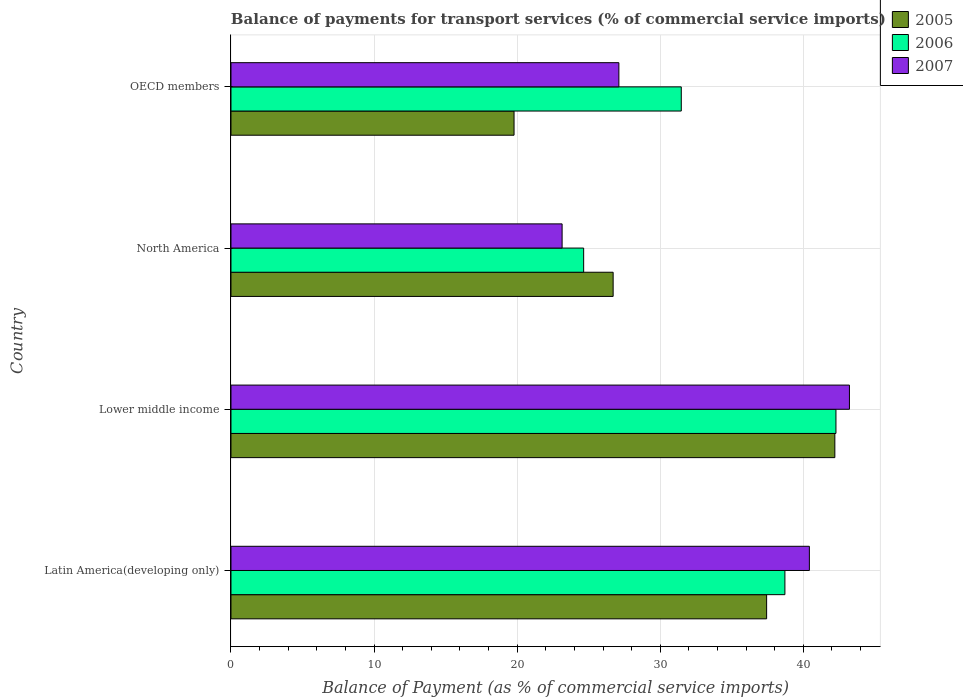How many bars are there on the 2nd tick from the bottom?
Offer a very short reply. 3. What is the label of the 2nd group of bars from the top?
Your answer should be compact. North America. What is the balance of payments for transport services in 2005 in Latin America(developing only)?
Keep it short and to the point. 37.43. Across all countries, what is the maximum balance of payments for transport services in 2007?
Provide a succinct answer. 43.22. Across all countries, what is the minimum balance of payments for transport services in 2005?
Provide a succinct answer. 19.78. In which country was the balance of payments for transport services in 2007 maximum?
Ensure brevity in your answer.  Lower middle income. In which country was the balance of payments for transport services in 2005 minimum?
Ensure brevity in your answer.  OECD members. What is the total balance of payments for transport services in 2006 in the graph?
Offer a terse response. 137.1. What is the difference between the balance of payments for transport services in 2006 in Lower middle income and that in North America?
Your response must be concise. 17.63. What is the difference between the balance of payments for transport services in 2006 in Lower middle income and the balance of payments for transport services in 2007 in Latin America(developing only)?
Ensure brevity in your answer.  1.86. What is the average balance of payments for transport services in 2006 per country?
Your answer should be very brief. 34.28. What is the difference between the balance of payments for transport services in 2006 and balance of payments for transport services in 2007 in Lower middle income?
Keep it short and to the point. -0.94. What is the ratio of the balance of payments for transport services in 2005 in Latin America(developing only) to that in OECD members?
Give a very brief answer. 1.89. What is the difference between the highest and the second highest balance of payments for transport services in 2007?
Offer a very short reply. 2.8. What is the difference between the highest and the lowest balance of payments for transport services in 2007?
Offer a terse response. 20.08. In how many countries, is the balance of payments for transport services in 2007 greater than the average balance of payments for transport services in 2007 taken over all countries?
Your answer should be very brief. 2. Is it the case that in every country, the sum of the balance of payments for transport services in 2006 and balance of payments for transport services in 2005 is greater than the balance of payments for transport services in 2007?
Offer a terse response. Yes. How many countries are there in the graph?
Your answer should be compact. 4. Does the graph contain any zero values?
Offer a very short reply. No. Where does the legend appear in the graph?
Your response must be concise. Top right. How many legend labels are there?
Your response must be concise. 3. What is the title of the graph?
Your answer should be compact. Balance of payments for transport services (% of commercial service imports). Does "2007" appear as one of the legend labels in the graph?
Your answer should be compact. Yes. What is the label or title of the X-axis?
Your response must be concise. Balance of Payment (as % of commercial service imports). What is the Balance of Payment (as % of commercial service imports) in 2005 in Latin America(developing only)?
Make the answer very short. 37.43. What is the Balance of Payment (as % of commercial service imports) of 2006 in Latin America(developing only)?
Your answer should be compact. 38.71. What is the Balance of Payment (as % of commercial service imports) of 2007 in Latin America(developing only)?
Offer a very short reply. 40.42. What is the Balance of Payment (as % of commercial service imports) in 2005 in Lower middle income?
Your answer should be compact. 42.2. What is the Balance of Payment (as % of commercial service imports) in 2006 in Lower middle income?
Ensure brevity in your answer.  42.28. What is the Balance of Payment (as % of commercial service imports) in 2007 in Lower middle income?
Your answer should be compact. 43.22. What is the Balance of Payment (as % of commercial service imports) of 2005 in North America?
Your answer should be compact. 26.71. What is the Balance of Payment (as % of commercial service imports) in 2006 in North America?
Offer a terse response. 24.65. What is the Balance of Payment (as % of commercial service imports) in 2007 in North America?
Provide a short and direct response. 23.14. What is the Balance of Payment (as % of commercial service imports) of 2005 in OECD members?
Provide a short and direct response. 19.78. What is the Balance of Payment (as % of commercial service imports) in 2006 in OECD members?
Give a very brief answer. 31.47. What is the Balance of Payment (as % of commercial service imports) in 2007 in OECD members?
Keep it short and to the point. 27.11. Across all countries, what is the maximum Balance of Payment (as % of commercial service imports) in 2005?
Provide a succinct answer. 42.2. Across all countries, what is the maximum Balance of Payment (as % of commercial service imports) in 2006?
Make the answer very short. 42.28. Across all countries, what is the maximum Balance of Payment (as % of commercial service imports) of 2007?
Offer a very short reply. 43.22. Across all countries, what is the minimum Balance of Payment (as % of commercial service imports) in 2005?
Offer a terse response. 19.78. Across all countries, what is the minimum Balance of Payment (as % of commercial service imports) in 2006?
Make the answer very short. 24.65. Across all countries, what is the minimum Balance of Payment (as % of commercial service imports) in 2007?
Provide a succinct answer. 23.14. What is the total Balance of Payment (as % of commercial service imports) in 2005 in the graph?
Your answer should be compact. 126.12. What is the total Balance of Payment (as % of commercial service imports) in 2006 in the graph?
Ensure brevity in your answer.  137.1. What is the total Balance of Payment (as % of commercial service imports) of 2007 in the graph?
Make the answer very short. 133.89. What is the difference between the Balance of Payment (as % of commercial service imports) of 2005 in Latin America(developing only) and that in Lower middle income?
Offer a terse response. -4.77. What is the difference between the Balance of Payment (as % of commercial service imports) in 2006 in Latin America(developing only) and that in Lower middle income?
Provide a short and direct response. -3.57. What is the difference between the Balance of Payment (as % of commercial service imports) in 2007 in Latin America(developing only) and that in Lower middle income?
Keep it short and to the point. -2.8. What is the difference between the Balance of Payment (as % of commercial service imports) of 2005 in Latin America(developing only) and that in North America?
Offer a terse response. 10.73. What is the difference between the Balance of Payment (as % of commercial service imports) in 2006 in Latin America(developing only) and that in North America?
Your response must be concise. 14.06. What is the difference between the Balance of Payment (as % of commercial service imports) of 2007 in Latin America(developing only) and that in North America?
Give a very brief answer. 17.28. What is the difference between the Balance of Payment (as % of commercial service imports) in 2005 in Latin America(developing only) and that in OECD members?
Make the answer very short. 17.65. What is the difference between the Balance of Payment (as % of commercial service imports) in 2006 in Latin America(developing only) and that in OECD members?
Ensure brevity in your answer.  7.24. What is the difference between the Balance of Payment (as % of commercial service imports) in 2007 in Latin America(developing only) and that in OECD members?
Make the answer very short. 13.31. What is the difference between the Balance of Payment (as % of commercial service imports) of 2005 in Lower middle income and that in North America?
Ensure brevity in your answer.  15.49. What is the difference between the Balance of Payment (as % of commercial service imports) of 2006 in Lower middle income and that in North America?
Offer a very short reply. 17.63. What is the difference between the Balance of Payment (as % of commercial service imports) of 2007 in Lower middle income and that in North America?
Your response must be concise. 20.08. What is the difference between the Balance of Payment (as % of commercial service imports) in 2005 in Lower middle income and that in OECD members?
Give a very brief answer. 22.42. What is the difference between the Balance of Payment (as % of commercial service imports) in 2006 in Lower middle income and that in OECD members?
Keep it short and to the point. 10.81. What is the difference between the Balance of Payment (as % of commercial service imports) of 2007 in Lower middle income and that in OECD members?
Your answer should be compact. 16.11. What is the difference between the Balance of Payment (as % of commercial service imports) of 2005 in North America and that in OECD members?
Make the answer very short. 6.93. What is the difference between the Balance of Payment (as % of commercial service imports) of 2006 in North America and that in OECD members?
Your answer should be very brief. -6.82. What is the difference between the Balance of Payment (as % of commercial service imports) in 2007 in North America and that in OECD members?
Your response must be concise. -3.97. What is the difference between the Balance of Payment (as % of commercial service imports) of 2005 in Latin America(developing only) and the Balance of Payment (as % of commercial service imports) of 2006 in Lower middle income?
Your answer should be very brief. -4.84. What is the difference between the Balance of Payment (as % of commercial service imports) in 2005 in Latin America(developing only) and the Balance of Payment (as % of commercial service imports) in 2007 in Lower middle income?
Make the answer very short. -5.79. What is the difference between the Balance of Payment (as % of commercial service imports) of 2006 in Latin America(developing only) and the Balance of Payment (as % of commercial service imports) of 2007 in Lower middle income?
Offer a terse response. -4.51. What is the difference between the Balance of Payment (as % of commercial service imports) of 2005 in Latin America(developing only) and the Balance of Payment (as % of commercial service imports) of 2006 in North America?
Your response must be concise. 12.79. What is the difference between the Balance of Payment (as % of commercial service imports) of 2005 in Latin America(developing only) and the Balance of Payment (as % of commercial service imports) of 2007 in North America?
Your answer should be very brief. 14.29. What is the difference between the Balance of Payment (as % of commercial service imports) of 2006 in Latin America(developing only) and the Balance of Payment (as % of commercial service imports) of 2007 in North America?
Provide a short and direct response. 15.57. What is the difference between the Balance of Payment (as % of commercial service imports) of 2005 in Latin America(developing only) and the Balance of Payment (as % of commercial service imports) of 2006 in OECD members?
Your response must be concise. 5.96. What is the difference between the Balance of Payment (as % of commercial service imports) in 2005 in Latin America(developing only) and the Balance of Payment (as % of commercial service imports) in 2007 in OECD members?
Your response must be concise. 10.33. What is the difference between the Balance of Payment (as % of commercial service imports) of 2006 in Latin America(developing only) and the Balance of Payment (as % of commercial service imports) of 2007 in OECD members?
Offer a terse response. 11.6. What is the difference between the Balance of Payment (as % of commercial service imports) in 2005 in Lower middle income and the Balance of Payment (as % of commercial service imports) in 2006 in North America?
Your response must be concise. 17.55. What is the difference between the Balance of Payment (as % of commercial service imports) in 2005 in Lower middle income and the Balance of Payment (as % of commercial service imports) in 2007 in North America?
Make the answer very short. 19.06. What is the difference between the Balance of Payment (as % of commercial service imports) of 2006 in Lower middle income and the Balance of Payment (as % of commercial service imports) of 2007 in North America?
Provide a succinct answer. 19.14. What is the difference between the Balance of Payment (as % of commercial service imports) of 2005 in Lower middle income and the Balance of Payment (as % of commercial service imports) of 2006 in OECD members?
Keep it short and to the point. 10.73. What is the difference between the Balance of Payment (as % of commercial service imports) of 2005 in Lower middle income and the Balance of Payment (as % of commercial service imports) of 2007 in OECD members?
Keep it short and to the point. 15.09. What is the difference between the Balance of Payment (as % of commercial service imports) in 2006 in Lower middle income and the Balance of Payment (as % of commercial service imports) in 2007 in OECD members?
Your answer should be very brief. 15.17. What is the difference between the Balance of Payment (as % of commercial service imports) of 2005 in North America and the Balance of Payment (as % of commercial service imports) of 2006 in OECD members?
Your response must be concise. -4.76. What is the difference between the Balance of Payment (as % of commercial service imports) of 2005 in North America and the Balance of Payment (as % of commercial service imports) of 2007 in OECD members?
Your response must be concise. -0.4. What is the difference between the Balance of Payment (as % of commercial service imports) of 2006 in North America and the Balance of Payment (as % of commercial service imports) of 2007 in OECD members?
Your response must be concise. -2.46. What is the average Balance of Payment (as % of commercial service imports) of 2005 per country?
Ensure brevity in your answer.  31.53. What is the average Balance of Payment (as % of commercial service imports) in 2006 per country?
Provide a succinct answer. 34.28. What is the average Balance of Payment (as % of commercial service imports) in 2007 per country?
Your answer should be very brief. 33.47. What is the difference between the Balance of Payment (as % of commercial service imports) in 2005 and Balance of Payment (as % of commercial service imports) in 2006 in Latin America(developing only)?
Keep it short and to the point. -1.28. What is the difference between the Balance of Payment (as % of commercial service imports) of 2005 and Balance of Payment (as % of commercial service imports) of 2007 in Latin America(developing only)?
Make the answer very short. -2.99. What is the difference between the Balance of Payment (as % of commercial service imports) in 2006 and Balance of Payment (as % of commercial service imports) in 2007 in Latin America(developing only)?
Offer a terse response. -1.71. What is the difference between the Balance of Payment (as % of commercial service imports) of 2005 and Balance of Payment (as % of commercial service imports) of 2006 in Lower middle income?
Provide a short and direct response. -0.08. What is the difference between the Balance of Payment (as % of commercial service imports) of 2005 and Balance of Payment (as % of commercial service imports) of 2007 in Lower middle income?
Keep it short and to the point. -1.02. What is the difference between the Balance of Payment (as % of commercial service imports) of 2006 and Balance of Payment (as % of commercial service imports) of 2007 in Lower middle income?
Keep it short and to the point. -0.94. What is the difference between the Balance of Payment (as % of commercial service imports) of 2005 and Balance of Payment (as % of commercial service imports) of 2006 in North America?
Your response must be concise. 2.06. What is the difference between the Balance of Payment (as % of commercial service imports) of 2005 and Balance of Payment (as % of commercial service imports) of 2007 in North America?
Offer a terse response. 3.57. What is the difference between the Balance of Payment (as % of commercial service imports) of 2006 and Balance of Payment (as % of commercial service imports) of 2007 in North America?
Provide a short and direct response. 1.51. What is the difference between the Balance of Payment (as % of commercial service imports) in 2005 and Balance of Payment (as % of commercial service imports) in 2006 in OECD members?
Provide a succinct answer. -11.69. What is the difference between the Balance of Payment (as % of commercial service imports) of 2005 and Balance of Payment (as % of commercial service imports) of 2007 in OECD members?
Provide a succinct answer. -7.33. What is the difference between the Balance of Payment (as % of commercial service imports) in 2006 and Balance of Payment (as % of commercial service imports) in 2007 in OECD members?
Provide a short and direct response. 4.36. What is the ratio of the Balance of Payment (as % of commercial service imports) in 2005 in Latin America(developing only) to that in Lower middle income?
Keep it short and to the point. 0.89. What is the ratio of the Balance of Payment (as % of commercial service imports) of 2006 in Latin America(developing only) to that in Lower middle income?
Your answer should be compact. 0.92. What is the ratio of the Balance of Payment (as % of commercial service imports) of 2007 in Latin America(developing only) to that in Lower middle income?
Your answer should be compact. 0.94. What is the ratio of the Balance of Payment (as % of commercial service imports) of 2005 in Latin America(developing only) to that in North America?
Offer a very short reply. 1.4. What is the ratio of the Balance of Payment (as % of commercial service imports) of 2006 in Latin America(developing only) to that in North America?
Make the answer very short. 1.57. What is the ratio of the Balance of Payment (as % of commercial service imports) in 2007 in Latin America(developing only) to that in North America?
Your response must be concise. 1.75. What is the ratio of the Balance of Payment (as % of commercial service imports) in 2005 in Latin America(developing only) to that in OECD members?
Your answer should be compact. 1.89. What is the ratio of the Balance of Payment (as % of commercial service imports) in 2006 in Latin America(developing only) to that in OECD members?
Ensure brevity in your answer.  1.23. What is the ratio of the Balance of Payment (as % of commercial service imports) of 2007 in Latin America(developing only) to that in OECD members?
Your answer should be very brief. 1.49. What is the ratio of the Balance of Payment (as % of commercial service imports) of 2005 in Lower middle income to that in North America?
Give a very brief answer. 1.58. What is the ratio of the Balance of Payment (as % of commercial service imports) of 2006 in Lower middle income to that in North America?
Provide a short and direct response. 1.72. What is the ratio of the Balance of Payment (as % of commercial service imports) of 2007 in Lower middle income to that in North America?
Offer a terse response. 1.87. What is the ratio of the Balance of Payment (as % of commercial service imports) of 2005 in Lower middle income to that in OECD members?
Make the answer very short. 2.13. What is the ratio of the Balance of Payment (as % of commercial service imports) in 2006 in Lower middle income to that in OECD members?
Keep it short and to the point. 1.34. What is the ratio of the Balance of Payment (as % of commercial service imports) in 2007 in Lower middle income to that in OECD members?
Offer a terse response. 1.59. What is the ratio of the Balance of Payment (as % of commercial service imports) of 2005 in North America to that in OECD members?
Your answer should be compact. 1.35. What is the ratio of the Balance of Payment (as % of commercial service imports) in 2006 in North America to that in OECD members?
Give a very brief answer. 0.78. What is the ratio of the Balance of Payment (as % of commercial service imports) in 2007 in North America to that in OECD members?
Provide a short and direct response. 0.85. What is the difference between the highest and the second highest Balance of Payment (as % of commercial service imports) of 2005?
Offer a terse response. 4.77. What is the difference between the highest and the second highest Balance of Payment (as % of commercial service imports) of 2006?
Keep it short and to the point. 3.57. What is the difference between the highest and the second highest Balance of Payment (as % of commercial service imports) of 2007?
Offer a terse response. 2.8. What is the difference between the highest and the lowest Balance of Payment (as % of commercial service imports) of 2005?
Your answer should be very brief. 22.42. What is the difference between the highest and the lowest Balance of Payment (as % of commercial service imports) of 2006?
Keep it short and to the point. 17.63. What is the difference between the highest and the lowest Balance of Payment (as % of commercial service imports) of 2007?
Your answer should be compact. 20.08. 